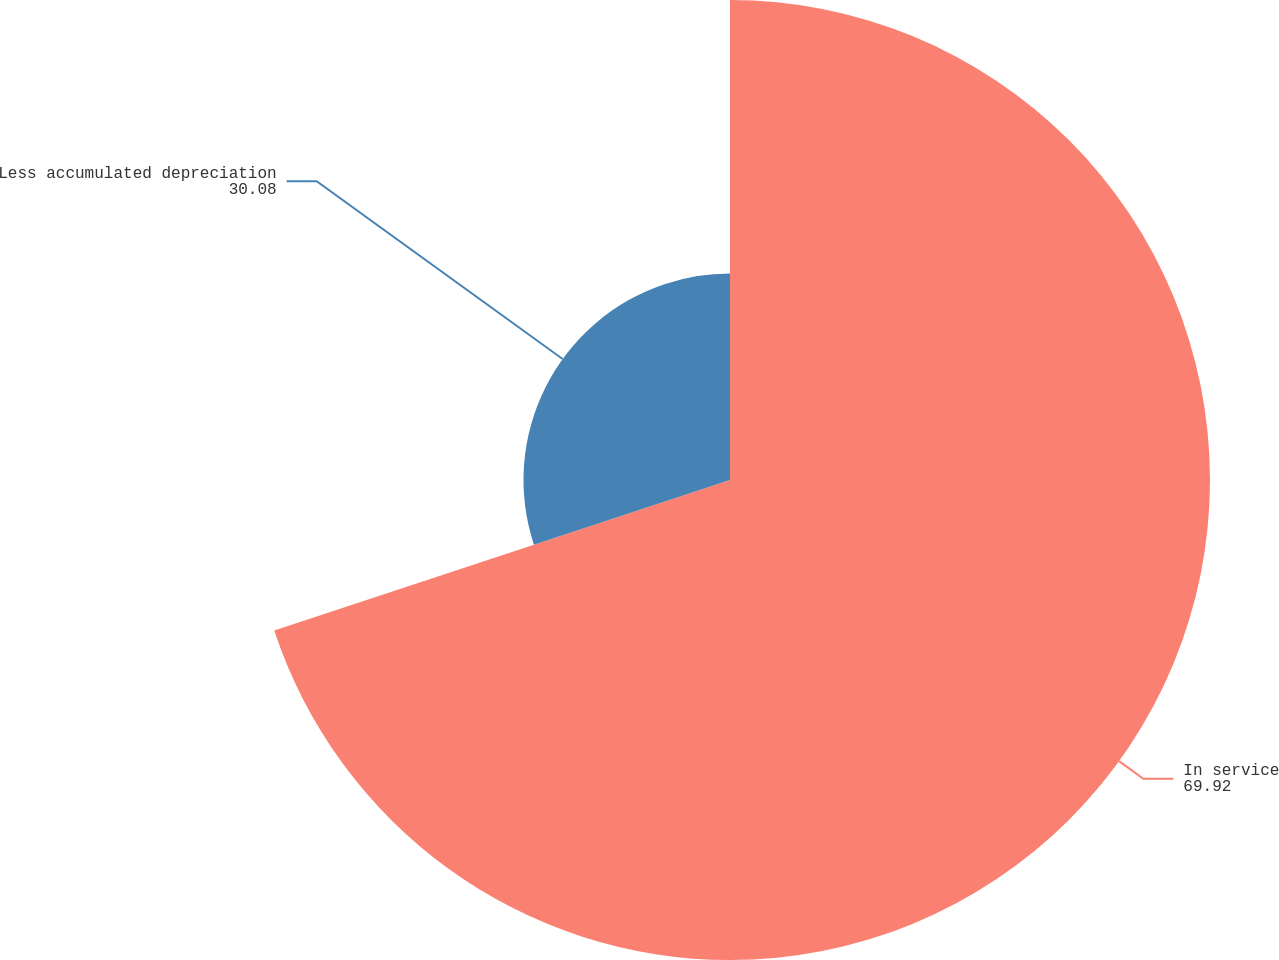Convert chart to OTSL. <chart><loc_0><loc_0><loc_500><loc_500><pie_chart><fcel>In service<fcel>Less accumulated depreciation<nl><fcel>69.92%<fcel>30.08%<nl></chart> 